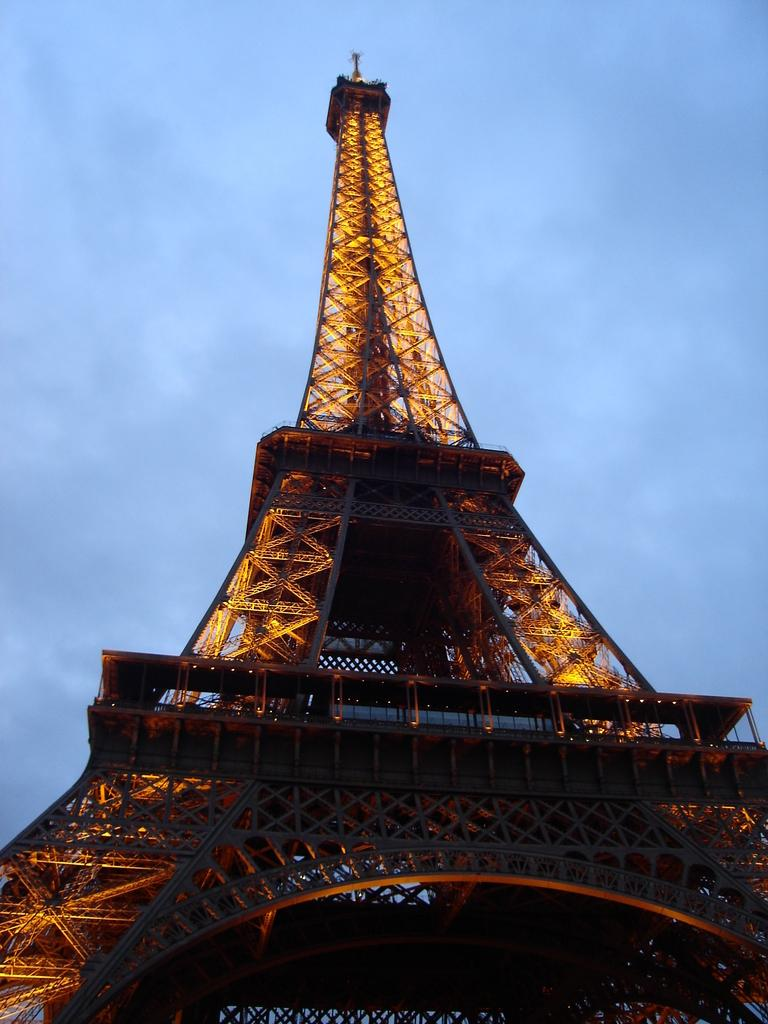What is the main subject in the center of the image? There is a tower in the center of the image. What feature can be observed on the tower? The tower has lights. What can be seen in the background of the image? The sky is visible in the background of the image. What book is the tower reading in the image? The tower is not reading a book in the image, as it is an inanimate object and cannot read. 